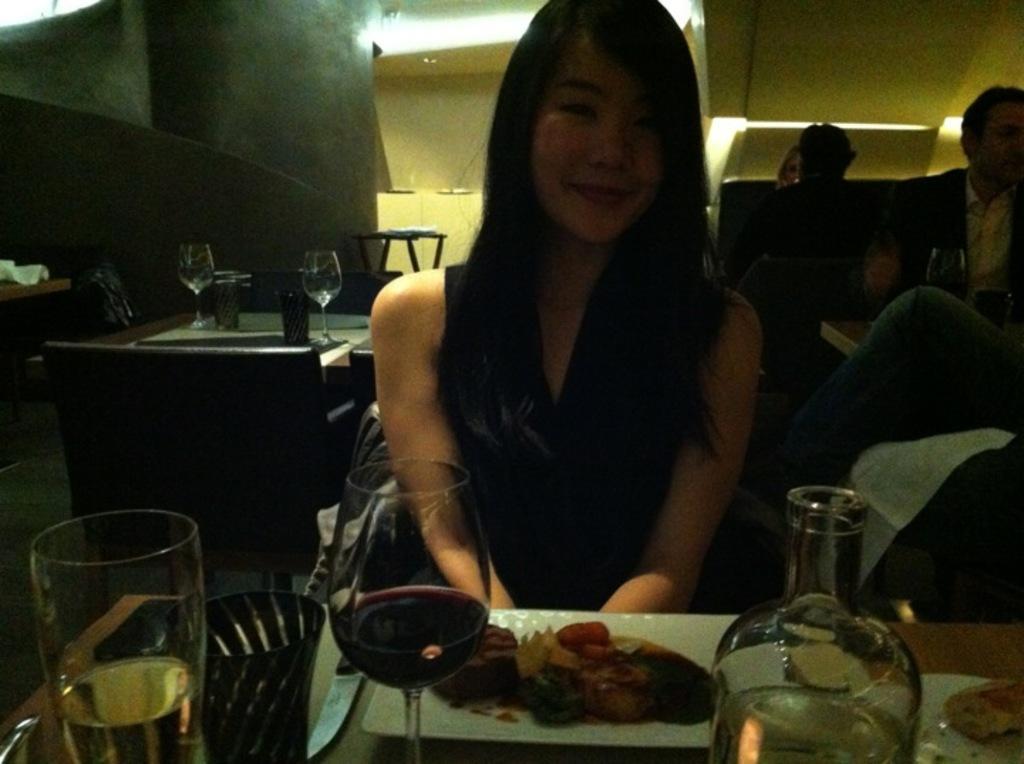How would you summarize this image in a sentence or two? In this image there is a glass in the bottom left hand corner and girl is sitting in the middle. 